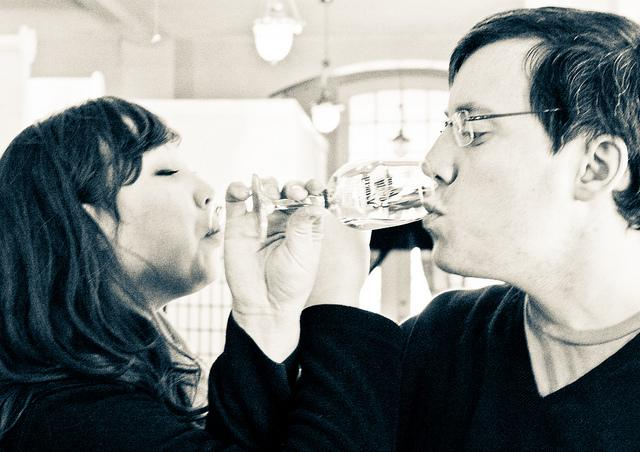What kind of beverage are the couple most likely drinking together? wine 